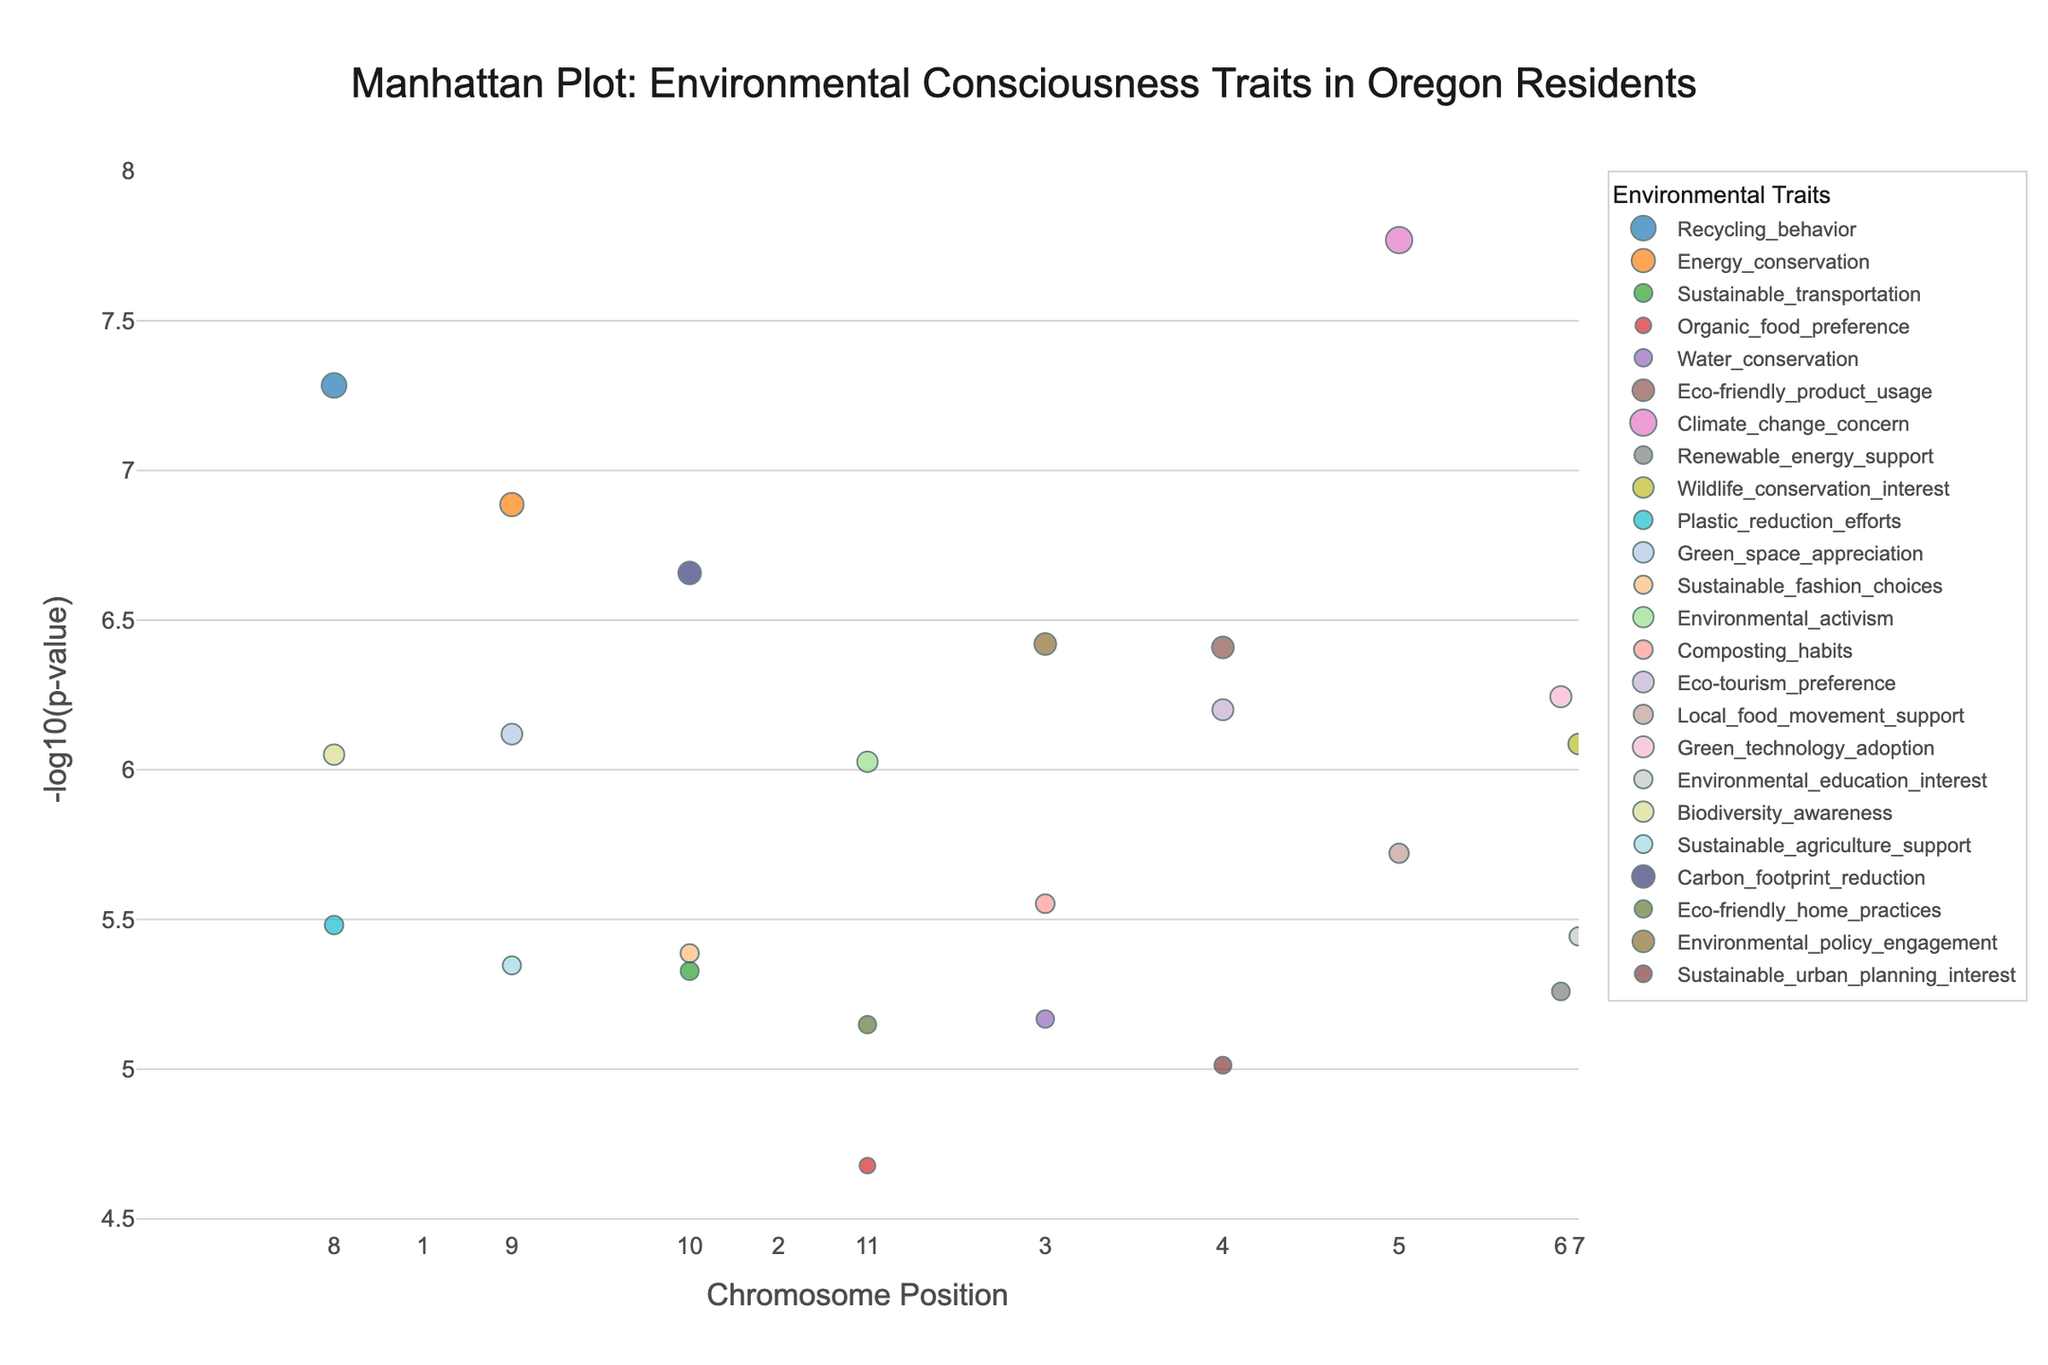What trait corresponds to the SNP with the smallest p-value? The smallest p-value will be indicated by the highest point on the plot. Locate the highest point and check the corresponding trait.
Answer: Climate_change_concern What is the title of the plot? The title is displayed at the top of the plot.
Answer: Manhattan Plot: Environmental Consciousness Traits in Oregon Residents Which trait has the highest number of significant SNPs (p < 5e-8)? Identify which trait has the most points below the threshold of p < 5e-8, which corresponds to a -log10(p) value above the threshold line.
Answer: Recycling_behavior What color represents the trait "Sustainable_fashion_choices"? The colors are explained in the legend. Look for "Sustainable_fashion_choices" in the legend and note its color.
Answer: A shade of brown or orange (exact colors may vary) What is the maximum -log10(p-value) observed in the plot and its corresponding SNP? Locate the highest point in the y-axis direction in the plot and record the -log10(p-value) and corresponding SNP.
Answer: 7.77, rs4680 How many SNPs for the trait "Plastic_reduction_efforts" are plotted? Determine the number of points related to the trait "Plastic_reduction_efforts."
Answer: 1 Which chromosome has the SNP with the highest significance for "Eco-friendly_product_usage"? Look for "Eco-friendly_product_usage" points and identify the chromosome of the highest point among them.
Answer: Chromosome 4 What is the chromosomal position range covered in the plot? The range of positions can be inferred from the x-axis, showing the minimum and maximum positions plotted.
Answer: 1234567 to 9012345 Name the SNP located at position 8901234 and the associated trait. Find the point at position 8901234 and note its SNP and trait from the figure.
Answer: rs9939609, Renewable_energy_support Which traits have their most significant SNPs on chromosome 1? Identify the traits whose significant SNPs (with the smallest p-values) occur on chromosome 1 from the plot.
Answer: Recycling_behavior, Energy_conservation 